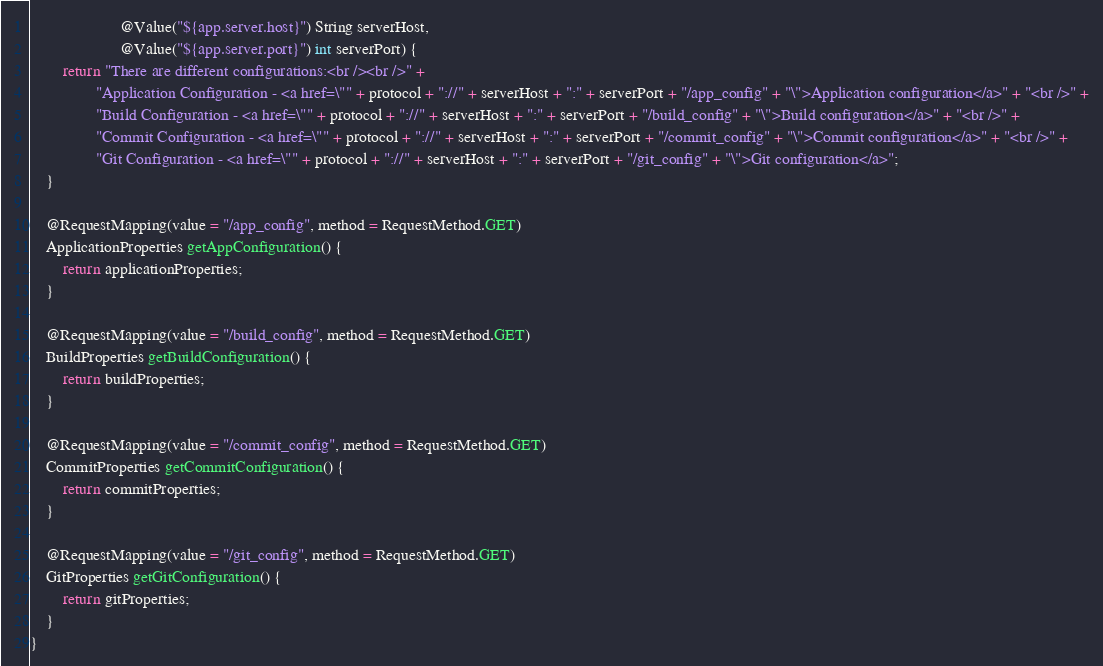<code> <loc_0><loc_0><loc_500><loc_500><_Java_>                      @Value("${app.server.host}") String serverHost,
                      @Value("${app.server.port}") int serverPort) {
        return "There are different configurations:<br /><br />" +
                "Application Configuration - <a href=\"" + protocol + "://" + serverHost + ":" + serverPort + "/app_config" + "\">Application configuration</a>" + "<br />" +
                "Build Configuration - <a href=\"" + protocol + "://" + serverHost + ":" + serverPort + "/build_config" + "\">Build configuration</a>" + "<br />" +
                "Commit Configuration - <a href=\"" + protocol + "://" + serverHost + ":" + serverPort + "/commit_config" + "\">Commit configuration</a>" + "<br />" +
                "Git Configuration - <a href=\"" + protocol + "://" + serverHost + ":" + serverPort + "/git_config" + "\">Git configuration</a>";
    }

    @RequestMapping(value = "/app_config", method = RequestMethod.GET)
    ApplicationProperties getAppConfiguration() {
        return applicationProperties;
    }

    @RequestMapping(value = "/build_config", method = RequestMethod.GET)
    BuildProperties getBuildConfiguration() {
        return buildProperties;
    }

    @RequestMapping(value = "/commit_config", method = RequestMethod.GET)
    CommitProperties getCommitConfiguration() {
        return commitProperties;
    }

    @RequestMapping(value = "/git_config", method = RequestMethod.GET)
    GitProperties getGitConfiguration() {
        return gitProperties;
    }
}</code> 